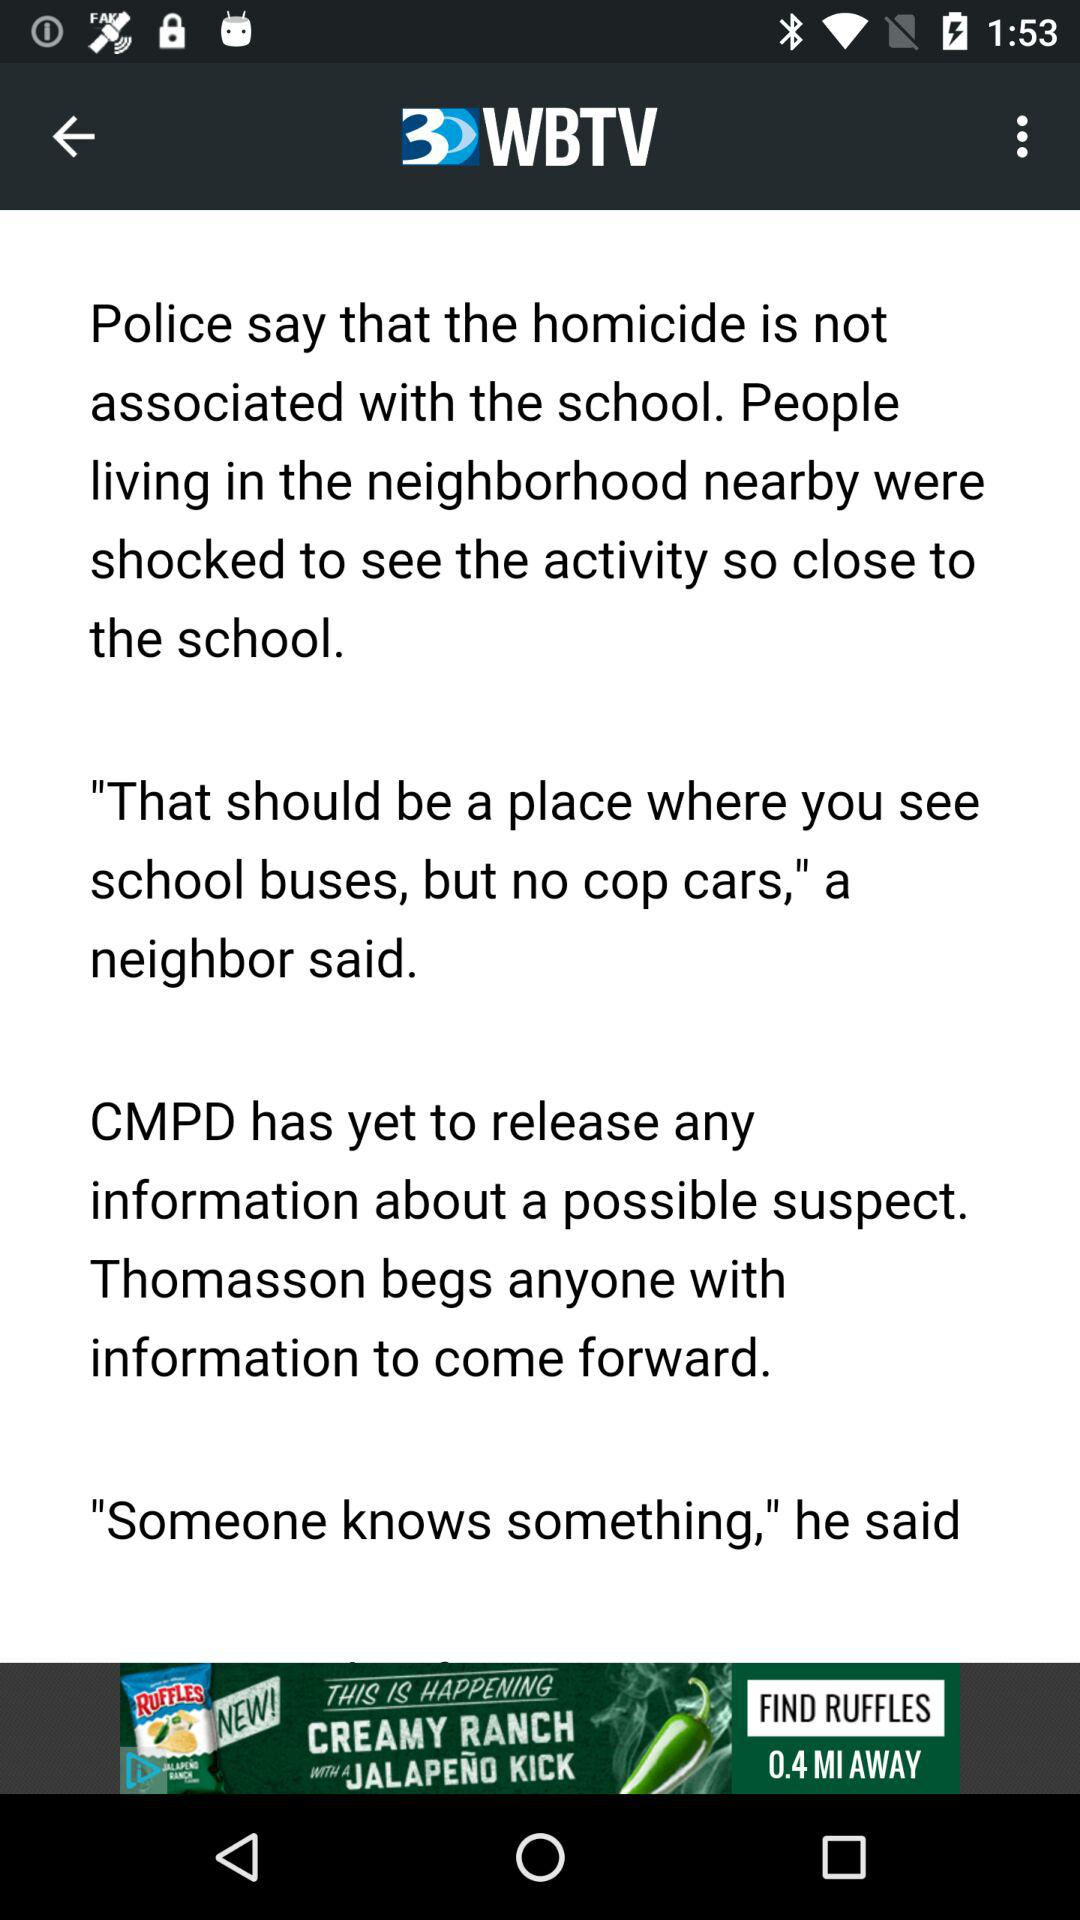What is the application name? The application name is "WBTV". 